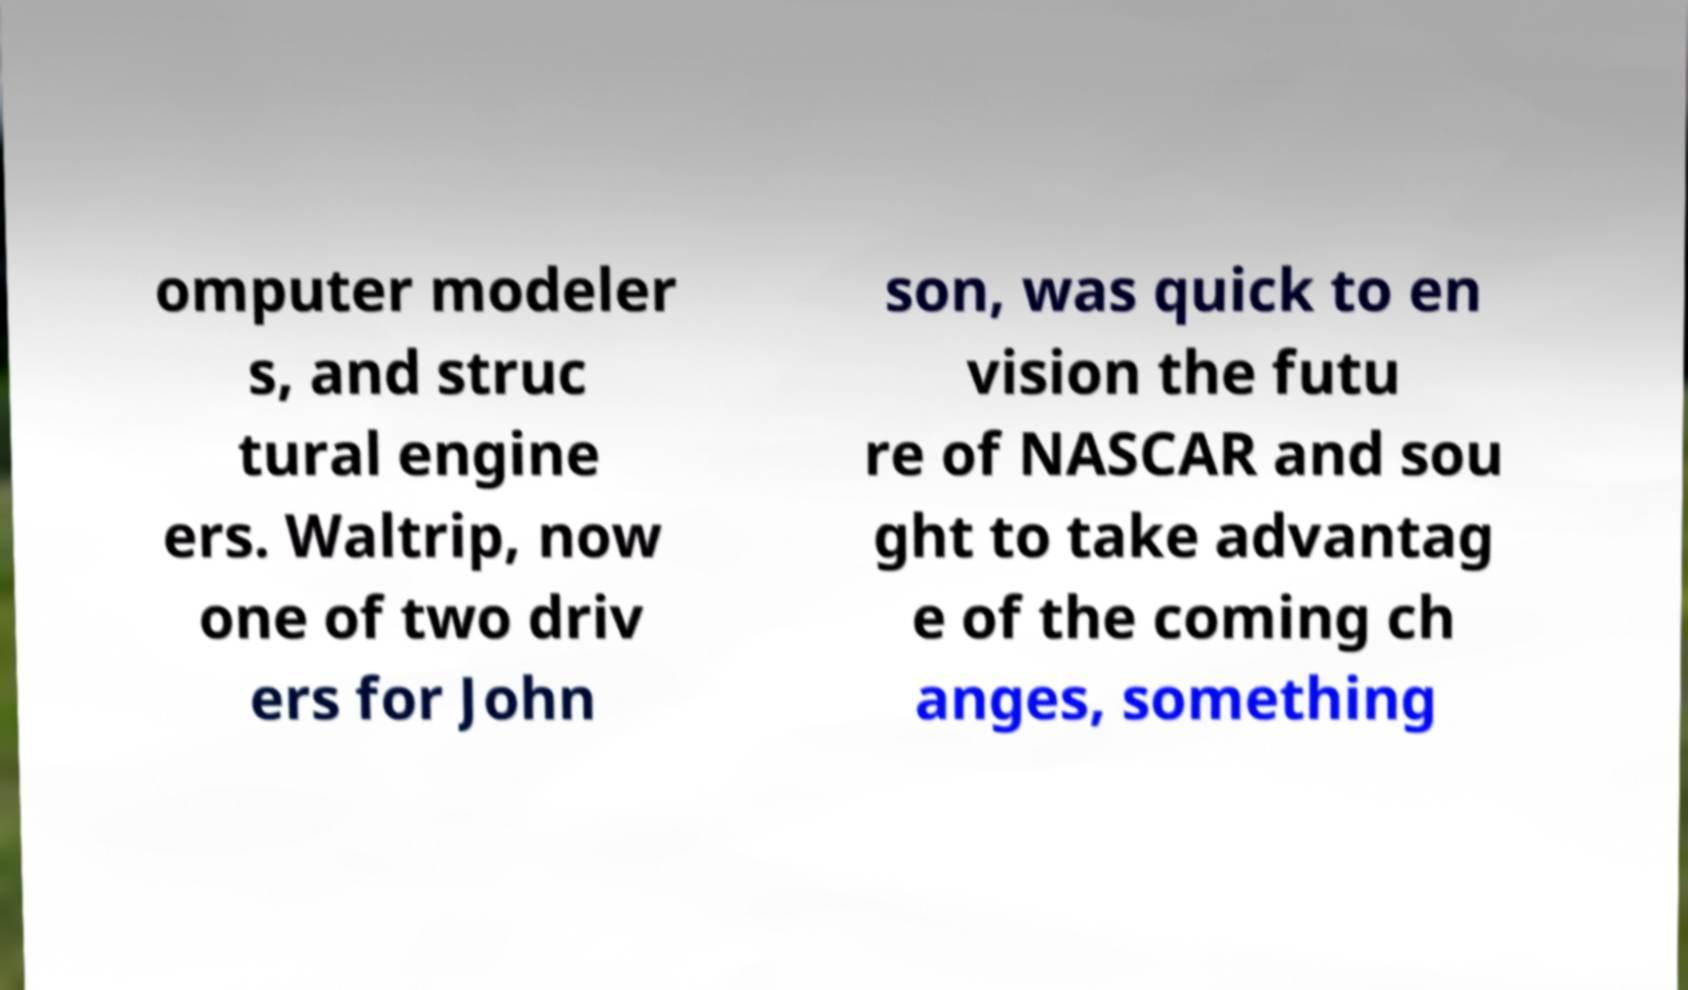There's text embedded in this image that I need extracted. Can you transcribe it verbatim? omputer modeler s, and struc tural engine ers. Waltrip, now one of two driv ers for John son, was quick to en vision the futu re of NASCAR and sou ght to take advantag e of the coming ch anges, something 